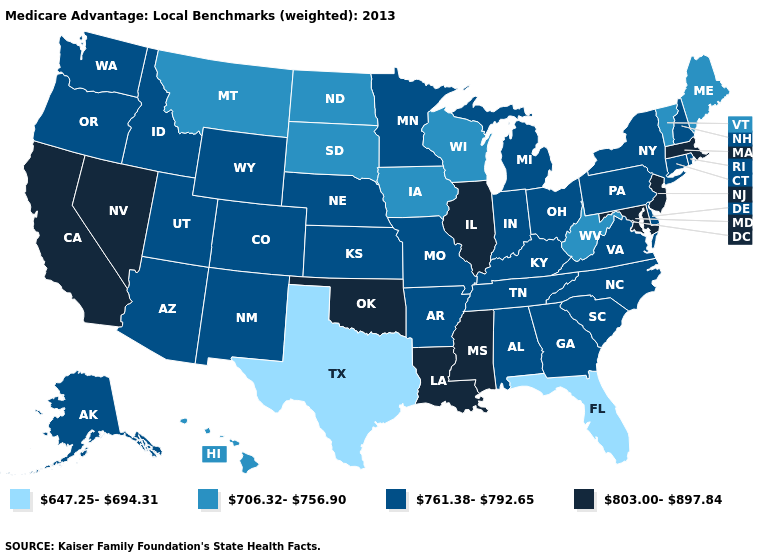Does Texas have the lowest value in the South?
Quick response, please. Yes. What is the value of North Carolina?
Answer briefly. 761.38-792.65. What is the value of Nebraska?
Write a very short answer. 761.38-792.65. Does the first symbol in the legend represent the smallest category?
Write a very short answer. Yes. What is the value of Wisconsin?
Give a very brief answer. 706.32-756.90. Does the first symbol in the legend represent the smallest category?
Give a very brief answer. Yes. What is the highest value in the South ?
Answer briefly. 803.00-897.84. Is the legend a continuous bar?
Give a very brief answer. No. Name the states that have a value in the range 803.00-897.84?
Give a very brief answer. California, Illinois, Louisiana, Massachusetts, Maryland, Mississippi, New Jersey, Nevada, Oklahoma. What is the value of Oregon?
Short answer required. 761.38-792.65. What is the value of Indiana?
Keep it brief. 761.38-792.65. Name the states that have a value in the range 803.00-897.84?
Concise answer only. California, Illinois, Louisiana, Massachusetts, Maryland, Mississippi, New Jersey, Nevada, Oklahoma. How many symbols are there in the legend?
Short answer required. 4. Does North Carolina have a higher value than Montana?
Answer briefly. Yes. Does New York have the same value as Massachusetts?
Quick response, please. No. 